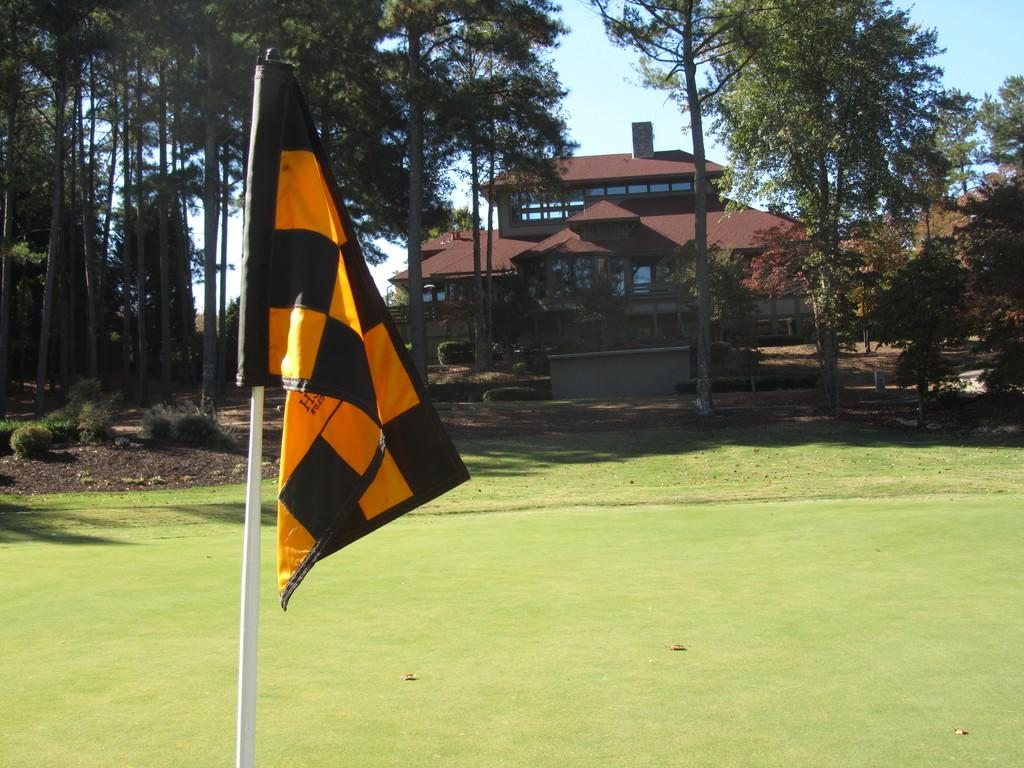What is attached to the pole in the image? There is a flag attached to the pole in the image. What type of vegetation is present in the image? There is grass, trees, and plants in the image. What type of structure can be seen in the image? There is a building in the image. What is visible in the background of the image? The sky is visible in the background of the image. What type of bread is being used to tell a story in the image? There is no bread or storytelling activity present in the image. 